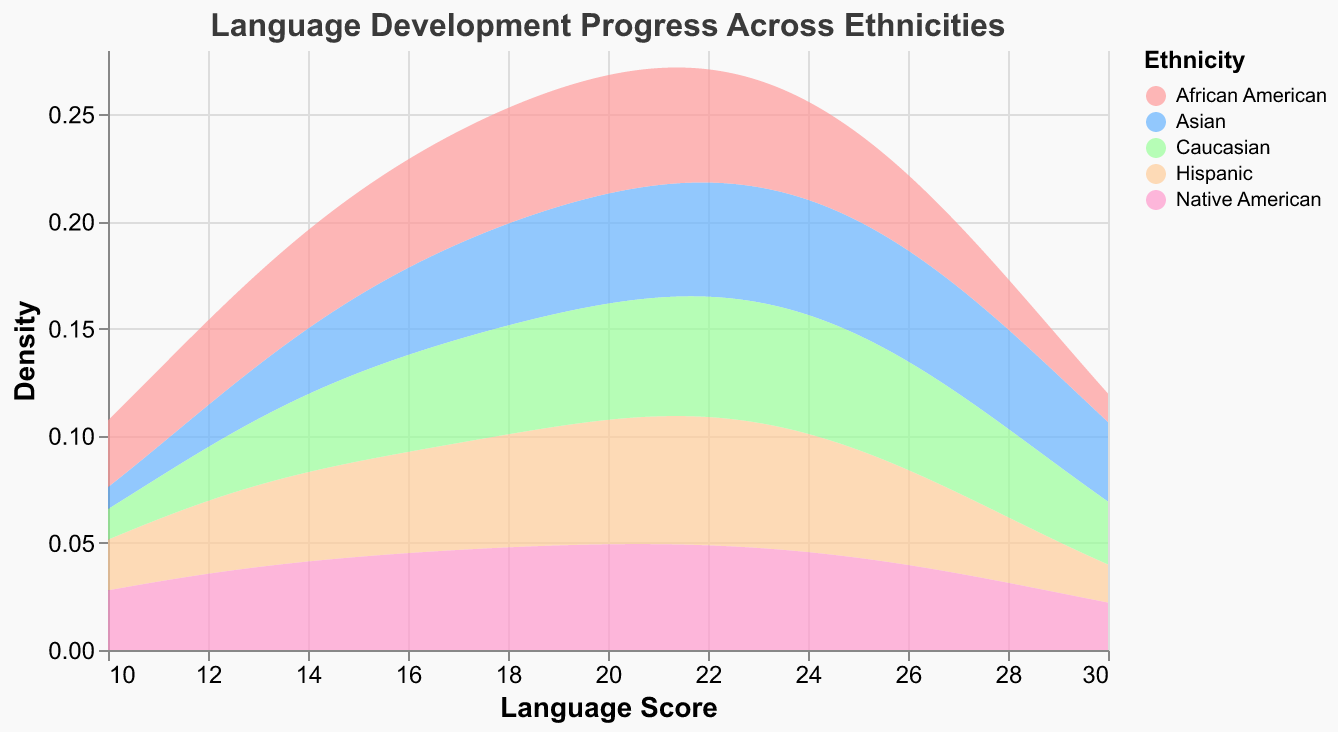What's the title of the plot? The title is usually located at the top of the plot and provides a summary of what the plot is about. In this case, it is listed as "Language Development Progress Across Ethnicities" in the provided code.
Answer: Language Development Progress Across Ethnicities What are the units on the x-axis? The x-axis represents the range of language scores. Checking the provided code, it is clear that it is labeled as "Language Score."
Answer: Language Score What does the y-axis measure in the plot? The y-axis measures "Density." According to the plot settings, it is clearly labeled as such and indicates the density or distribution of the Language Scores.
Answer: Density Which ethnicity shows the highest density around a language score of 30? By examining the plot, we look for the peak near the language score of 30. The data and color legend help us identify that the Asian group has the peak density closest to 30.
Answer: Asian How does the language development density of Native American children compare to Hispanic children around a score of 22? The curve for Native American children shows a higher density than that for Hispanic children around the score of 22, indicating more Native American children score around that value compared to Hispanic children.
Answer: Higher Which ethnic group has the lowest density peak, and at what approximate score does it occur? By looking at the plot, we find the curve with the lowest peak. The curve for African American children is the lowest, peaking around a language score of 10.
Answer: African American, 10 What is the range of language scores covered in the plot? Observing the x-axis, the plot displays language scores ranging from 10 to 30.
Answer: 10 to 30 At what score do Caucasian children show the highest density? By examining the curve corresponding to Caucasian children, we find the highest peak, which is around a score of 29.
Answer: 29 Compare the density of language scores between African American and Native American children at around 15. By checking the values at a score of 15 on the x-axis, the plot indicates that African American children have a lower density compared to Native American children.
Answer: Lower Which two ethnic groups have the most similar density curves overall? Observing the general shape and trends of the density curves across the score range, the curves for Hispanic and Native American children are quite similar.
Answer: Hispanic and Native American 